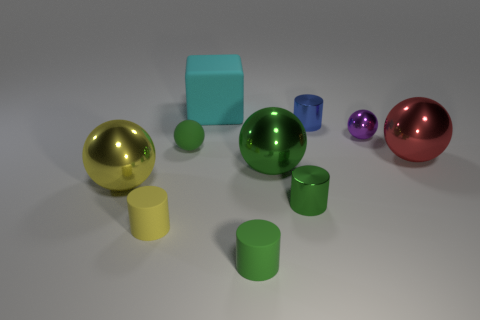Subtract all green shiny cylinders. How many cylinders are left? 3 Subtract 2 cylinders. How many cylinders are left? 2 Subtract all yellow cylinders. How many cylinders are left? 3 Subtract all cubes. How many objects are left? 9 Subtract all blue blocks. How many green balls are left? 2 Add 6 small rubber things. How many small rubber things are left? 9 Add 1 cyan things. How many cyan things exist? 2 Subtract 0 cyan cylinders. How many objects are left? 10 Subtract all yellow cylinders. Subtract all yellow cubes. How many cylinders are left? 3 Subtract all red things. Subtract all green metal objects. How many objects are left? 7 